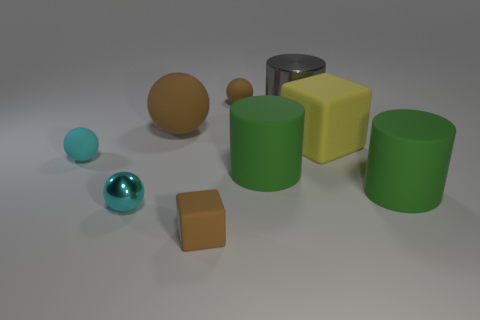Does the large matte ball have the same color as the small block?
Your response must be concise. Yes. How many other objects are the same material as the yellow block?
Ensure brevity in your answer.  6. The tiny matte sphere that is left of the small brown matte object behind the thing that is on the left side of the tiny cyan shiny sphere is what color?
Offer a terse response. Cyan. Are the big block and the large brown sphere made of the same material?
Ensure brevity in your answer.  Yes. There is a gray metal thing; what number of rubber spheres are to the right of it?
Ensure brevity in your answer.  0. What is the size of the other cyan thing that is the same shape as the small cyan rubber object?
Provide a succinct answer. Small. How many cyan things are either matte objects or rubber cubes?
Your answer should be very brief. 1. There is a metallic thing that is in front of the tiny cyan matte thing; how many matte blocks are left of it?
Provide a short and direct response. 0. What number of other objects are there of the same shape as the gray thing?
Ensure brevity in your answer.  2. There is a small thing that is the same color as the tiny block; what material is it?
Keep it short and to the point. Rubber. 